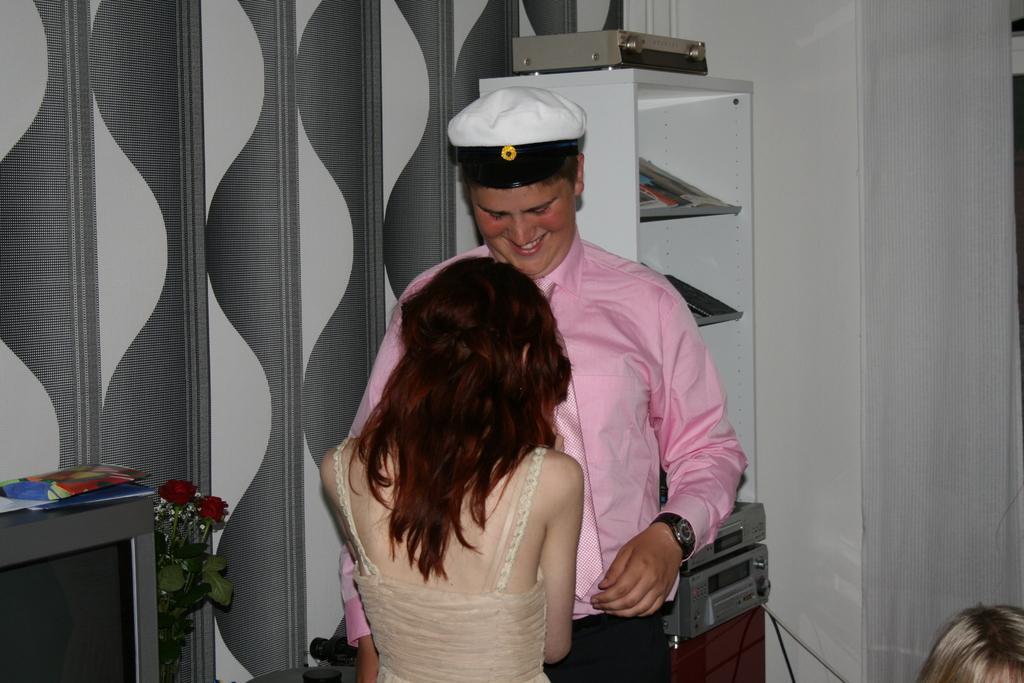Please provide a concise description of this image. In this image we can see a man and a lady standing. On the left there is a television and we can see papers placed on the television. There is a flower bouquet. In the background there is a rack and we can see things placed in the rack. At the bottom there is a person. We can see a wall and a curtain. 